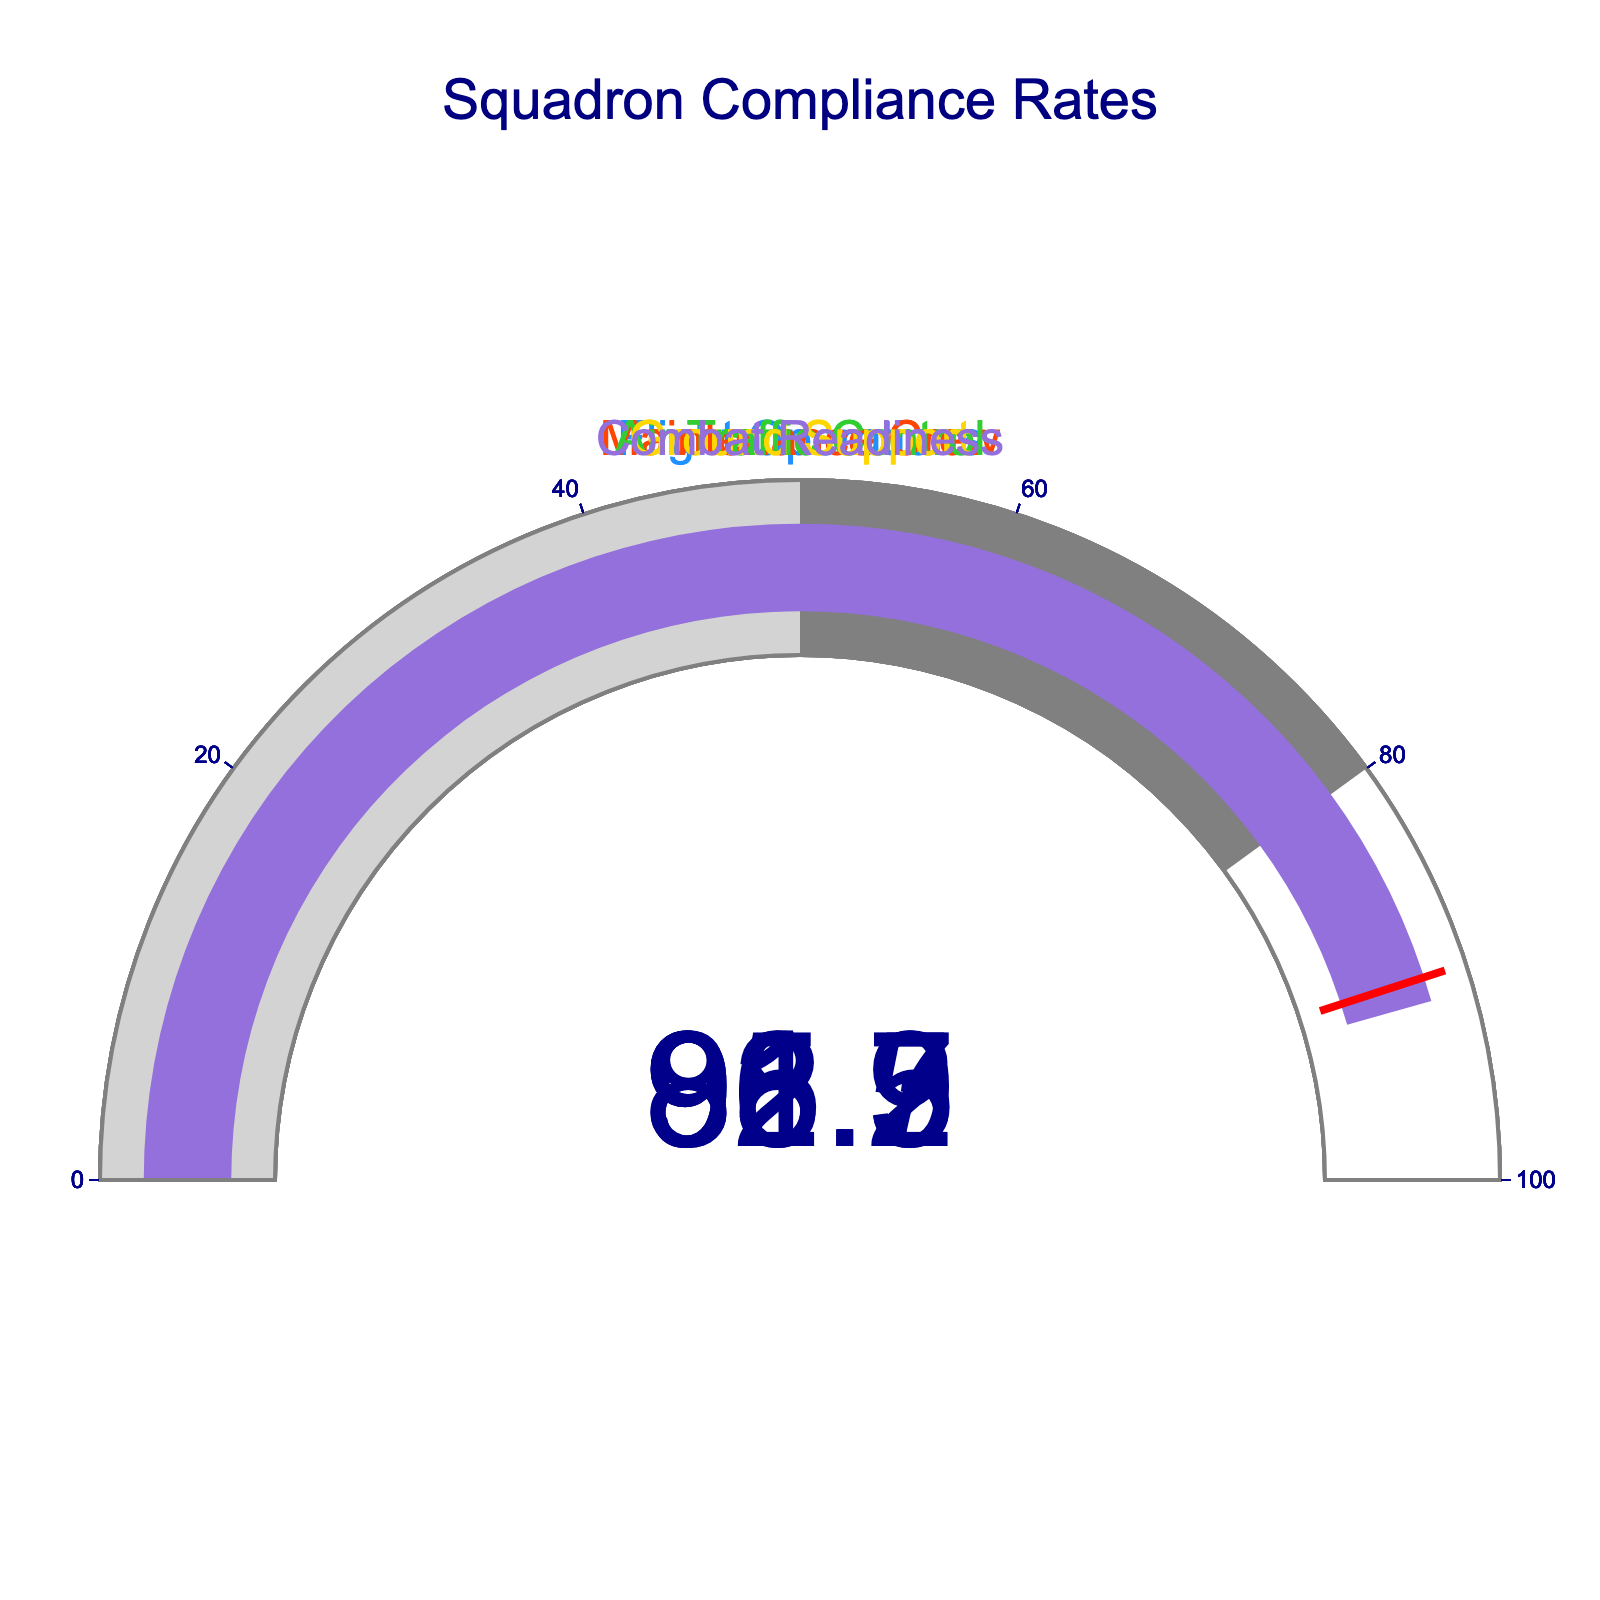What is the compliance rate for Flight Operations? The value indicated on the gauge for Flight Operations is 92.5.
Answer: 92.5 Which squadron has the highest compliance rate? By examining all the gauges, the one with the highest value is Air Traffic Control with 95.3.
Answer: Air Traffic Control What is the compliance rate for Ground Support? The value indicated on the gauge for Ground Support is 86.9.
Answer: 86.9 Compare the compliance rates of Maintenance Crew and Combat Readiness. Which one is higher? Maintenance Crew's value is 88.7, and Combat Readiness's value is 91.2. Therefore, Combat Readiness has a higher compliance rate.
Answer: Combat Readiness Are there any squadrons with a compliance rate below 90? The gauges for Ground Support (86.9) and Maintenance Crew (88.7) show values below 90.
Answer: Yes, Ground Support and Maintenance Crew What is the average compliance rate of all the squadrons? Sum the compliance rates (92.5 + 88.7 + 95.3 + 86.9 + 91.2 = 454.6). Divide by the number of squadrons (454.6 / 5 = 90.92).
Answer: 90.92 What is the difference in compliance rate between the squadron with the highest and lowest rates? The highest rate is 95.3 (Air Traffic Control), and the lowest is 86.9 (Ground Support). Subtract the lowest from the highest (95.3 - 86.9 = 8.4).
Answer: 8.4 Are there any compliance rates exactly at or below the threshold of 90? By examining the gauges, Maintenance Crew (88.7) and Ground Support (86.9) are below 90, none are exactly at 90.
Answer: Yes, there are rates below 90 